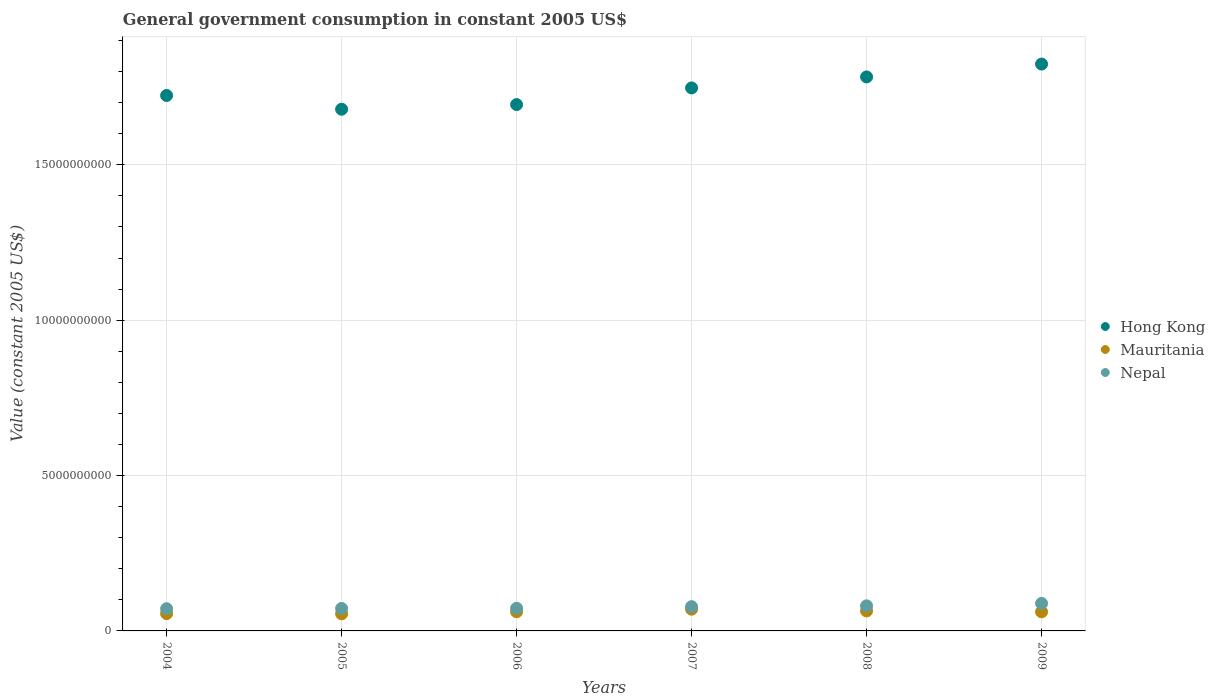How many different coloured dotlines are there?
Your response must be concise. 3. Is the number of dotlines equal to the number of legend labels?
Ensure brevity in your answer.  Yes. What is the government conusmption in Mauritania in 2009?
Offer a terse response. 6.14e+08. Across all years, what is the maximum government conusmption in Mauritania?
Your answer should be compact. 7.00e+08. Across all years, what is the minimum government conusmption in Hong Kong?
Offer a terse response. 1.68e+1. In which year was the government conusmption in Mauritania maximum?
Your answer should be very brief. 2007. In which year was the government conusmption in Hong Kong minimum?
Make the answer very short. 2005. What is the total government conusmption in Mauritania in the graph?
Your response must be concise. 3.68e+09. What is the difference between the government conusmption in Nepal in 2006 and that in 2008?
Keep it short and to the point. -7.78e+07. What is the difference between the government conusmption in Mauritania in 2007 and the government conusmption in Nepal in 2008?
Your answer should be very brief. -1.07e+08. What is the average government conusmption in Mauritania per year?
Offer a terse response. 6.13e+08. In the year 2005, what is the difference between the government conusmption in Mauritania and government conusmption in Hong Kong?
Offer a terse response. -1.62e+1. What is the ratio of the government conusmption in Hong Kong in 2004 to that in 2006?
Keep it short and to the point. 1.02. Is the difference between the government conusmption in Mauritania in 2004 and 2006 greater than the difference between the government conusmption in Hong Kong in 2004 and 2006?
Offer a very short reply. No. What is the difference between the highest and the second highest government conusmption in Nepal?
Offer a very short reply. 7.83e+07. What is the difference between the highest and the lowest government conusmption in Mauritania?
Your response must be concise. 1.49e+08. In how many years, is the government conusmption in Mauritania greater than the average government conusmption in Mauritania taken over all years?
Ensure brevity in your answer.  4. Does the government conusmption in Hong Kong monotonically increase over the years?
Provide a short and direct response. No. Is the government conusmption in Hong Kong strictly greater than the government conusmption in Nepal over the years?
Keep it short and to the point. Yes. How many years are there in the graph?
Give a very brief answer. 6. Are the values on the major ticks of Y-axis written in scientific E-notation?
Offer a terse response. No. How are the legend labels stacked?
Your answer should be very brief. Vertical. What is the title of the graph?
Provide a short and direct response. General government consumption in constant 2005 US$. Does "Hungary" appear as one of the legend labels in the graph?
Your answer should be compact. No. What is the label or title of the X-axis?
Provide a short and direct response. Years. What is the label or title of the Y-axis?
Make the answer very short. Value (constant 2005 US$). What is the Value (constant 2005 US$) in Hong Kong in 2004?
Your answer should be compact. 1.72e+1. What is the Value (constant 2005 US$) in Mauritania in 2004?
Make the answer very short. 5.56e+08. What is the Value (constant 2005 US$) of Nepal in 2004?
Your response must be concise. 7.15e+08. What is the Value (constant 2005 US$) of Hong Kong in 2005?
Give a very brief answer. 1.68e+1. What is the Value (constant 2005 US$) of Mauritania in 2005?
Ensure brevity in your answer.  5.51e+08. What is the Value (constant 2005 US$) in Nepal in 2005?
Make the answer very short. 7.24e+08. What is the Value (constant 2005 US$) of Hong Kong in 2006?
Provide a short and direct response. 1.69e+1. What is the Value (constant 2005 US$) in Mauritania in 2006?
Make the answer very short. 6.17e+08. What is the Value (constant 2005 US$) of Nepal in 2006?
Your answer should be very brief. 7.29e+08. What is the Value (constant 2005 US$) in Hong Kong in 2007?
Give a very brief answer. 1.75e+1. What is the Value (constant 2005 US$) of Mauritania in 2007?
Offer a very short reply. 7.00e+08. What is the Value (constant 2005 US$) in Nepal in 2007?
Offer a terse response. 7.81e+08. What is the Value (constant 2005 US$) of Hong Kong in 2008?
Ensure brevity in your answer.  1.78e+1. What is the Value (constant 2005 US$) of Mauritania in 2008?
Offer a terse response. 6.43e+08. What is the Value (constant 2005 US$) of Nepal in 2008?
Ensure brevity in your answer.  8.07e+08. What is the Value (constant 2005 US$) in Hong Kong in 2009?
Keep it short and to the point. 1.82e+1. What is the Value (constant 2005 US$) of Mauritania in 2009?
Make the answer very short. 6.14e+08. What is the Value (constant 2005 US$) in Nepal in 2009?
Your response must be concise. 8.85e+08. Across all years, what is the maximum Value (constant 2005 US$) in Hong Kong?
Make the answer very short. 1.82e+1. Across all years, what is the maximum Value (constant 2005 US$) of Mauritania?
Offer a terse response. 7.00e+08. Across all years, what is the maximum Value (constant 2005 US$) in Nepal?
Your response must be concise. 8.85e+08. Across all years, what is the minimum Value (constant 2005 US$) in Hong Kong?
Offer a very short reply. 1.68e+1. Across all years, what is the minimum Value (constant 2005 US$) in Mauritania?
Provide a short and direct response. 5.51e+08. Across all years, what is the minimum Value (constant 2005 US$) in Nepal?
Your response must be concise. 7.15e+08. What is the total Value (constant 2005 US$) in Hong Kong in the graph?
Keep it short and to the point. 1.04e+11. What is the total Value (constant 2005 US$) of Mauritania in the graph?
Your answer should be compact. 3.68e+09. What is the total Value (constant 2005 US$) of Nepal in the graph?
Your answer should be very brief. 4.64e+09. What is the difference between the Value (constant 2005 US$) in Hong Kong in 2004 and that in 2005?
Ensure brevity in your answer.  4.43e+08. What is the difference between the Value (constant 2005 US$) in Mauritania in 2004 and that in 2005?
Provide a succinct answer. 5.46e+06. What is the difference between the Value (constant 2005 US$) of Nepal in 2004 and that in 2005?
Make the answer very short. -8.87e+06. What is the difference between the Value (constant 2005 US$) of Hong Kong in 2004 and that in 2006?
Provide a succinct answer. 2.93e+08. What is the difference between the Value (constant 2005 US$) in Mauritania in 2004 and that in 2006?
Give a very brief answer. -6.05e+07. What is the difference between the Value (constant 2005 US$) of Nepal in 2004 and that in 2006?
Make the answer very short. -1.43e+07. What is the difference between the Value (constant 2005 US$) of Hong Kong in 2004 and that in 2007?
Your response must be concise. -2.43e+08. What is the difference between the Value (constant 2005 US$) of Mauritania in 2004 and that in 2007?
Offer a very short reply. -1.44e+08. What is the difference between the Value (constant 2005 US$) of Nepal in 2004 and that in 2007?
Give a very brief answer. -6.66e+07. What is the difference between the Value (constant 2005 US$) of Hong Kong in 2004 and that in 2008?
Make the answer very short. -5.97e+08. What is the difference between the Value (constant 2005 US$) of Mauritania in 2004 and that in 2008?
Give a very brief answer. -8.71e+07. What is the difference between the Value (constant 2005 US$) in Nepal in 2004 and that in 2008?
Ensure brevity in your answer.  -9.21e+07. What is the difference between the Value (constant 2005 US$) in Hong Kong in 2004 and that in 2009?
Your answer should be compact. -1.01e+09. What is the difference between the Value (constant 2005 US$) of Mauritania in 2004 and that in 2009?
Keep it short and to the point. -5.82e+07. What is the difference between the Value (constant 2005 US$) in Nepal in 2004 and that in 2009?
Your response must be concise. -1.70e+08. What is the difference between the Value (constant 2005 US$) of Hong Kong in 2005 and that in 2006?
Give a very brief answer. -1.50e+08. What is the difference between the Value (constant 2005 US$) of Mauritania in 2005 and that in 2006?
Your answer should be very brief. -6.60e+07. What is the difference between the Value (constant 2005 US$) in Nepal in 2005 and that in 2006?
Your answer should be very brief. -5.47e+06. What is the difference between the Value (constant 2005 US$) in Hong Kong in 2005 and that in 2007?
Your answer should be very brief. -6.85e+08. What is the difference between the Value (constant 2005 US$) of Mauritania in 2005 and that in 2007?
Your answer should be very brief. -1.49e+08. What is the difference between the Value (constant 2005 US$) in Nepal in 2005 and that in 2007?
Keep it short and to the point. -5.77e+07. What is the difference between the Value (constant 2005 US$) in Hong Kong in 2005 and that in 2008?
Make the answer very short. -1.04e+09. What is the difference between the Value (constant 2005 US$) in Mauritania in 2005 and that in 2008?
Ensure brevity in your answer.  -9.26e+07. What is the difference between the Value (constant 2005 US$) of Nepal in 2005 and that in 2008?
Your response must be concise. -8.33e+07. What is the difference between the Value (constant 2005 US$) of Hong Kong in 2005 and that in 2009?
Offer a very short reply. -1.45e+09. What is the difference between the Value (constant 2005 US$) in Mauritania in 2005 and that in 2009?
Ensure brevity in your answer.  -6.36e+07. What is the difference between the Value (constant 2005 US$) of Nepal in 2005 and that in 2009?
Offer a very short reply. -1.62e+08. What is the difference between the Value (constant 2005 US$) of Hong Kong in 2006 and that in 2007?
Provide a short and direct response. -5.36e+08. What is the difference between the Value (constant 2005 US$) of Mauritania in 2006 and that in 2007?
Give a very brief answer. -8.31e+07. What is the difference between the Value (constant 2005 US$) of Nepal in 2006 and that in 2007?
Offer a very short reply. -5.22e+07. What is the difference between the Value (constant 2005 US$) of Hong Kong in 2006 and that in 2008?
Ensure brevity in your answer.  -8.89e+08. What is the difference between the Value (constant 2005 US$) in Mauritania in 2006 and that in 2008?
Give a very brief answer. -2.66e+07. What is the difference between the Value (constant 2005 US$) of Nepal in 2006 and that in 2008?
Ensure brevity in your answer.  -7.78e+07. What is the difference between the Value (constant 2005 US$) in Hong Kong in 2006 and that in 2009?
Keep it short and to the point. -1.30e+09. What is the difference between the Value (constant 2005 US$) of Mauritania in 2006 and that in 2009?
Ensure brevity in your answer.  2.38e+06. What is the difference between the Value (constant 2005 US$) of Nepal in 2006 and that in 2009?
Offer a terse response. -1.56e+08. What is the difference between the Value (constant 2005 US$) of Hong Kong in 2007 and that in 2008?
Give a very brief answer. -3.54e+08. What is the difference between the Value (constant 2005 US$) of Mauritania in 2007 and that in 2008?
Offer a very short reply. 5.65e+07. What is the difference between the Value (constant 2005 US$) of Nepal in 2007 and that in 2008?
Provide a short and direct response. -2.56e+07. What is the difference between the Value (constant 2005 US$) of Hong Kong in 2007 and that in 2009?
Provide a short and direct response. -7.68e+08. What is the difference between the Value (constant 2005 US$) in Mauritania in 2007 and that in 2009?
Your answer should be very brief. 8.54e+07. What is the difference between the Value (constant 2005 US$) of Nepal in 2007 and that in 2009?
Your answer should be compact. -1.04e+08. What is the difference between the Value (constant 2005 US$) of Hong Kong in 2008 and that in 2009?
Make the answer very short. -4.14e+08. What is the difference between the Value (constant 2005 US$) in Mauritania in 2008 and that in 2009?
Offer a terse response. 2.89e+07. What is the difference between the Value (constant 2005 US$) in Nepal in 2008 and that in 2009?
Give a very brief answer. -7.83e+07. What is the difference between the Value (constant 2005 US$) of Hong Kong in 2004 and the Value (constant 2005 US$) of Mauritania in 2005?
Offer a terse response. 1.67e+1. What is the difference between the Value (constant 2005 US$) in Hong Kong in 2004 and the Value (constant 2005 US$) in Nepal in 2005?
Offer a terse response. 1.65e+1. What is the difference between the Value (constant 2005 US$) of Mauritania in 2004 and the Value (constant 2005 US$) of Nepal in 2005?
Your answer should be very brief. -1.67e+08. What is the difference between the Value (constant 2005 US$) of Hong Kong in 2004 and the Value (constant 2005 US$) of Mauritania in 2006?
Give a very brief answer. 1.66e+1. What is the difference between the Value (constant 2005 US$) of Hong Kong in 2004 and the Value (constant 2005 US$) of Nepal in 2006?
Your response must be concise. 1.65e+1. What is the difference between the Value (constant 2005 US$) in Mauritania in 2004 and the Value (constant 2005 US$) in Nepal in 2006?
Offer a very short reply. -1.73e+08. What is the difference between the Value (constant 2005 US$) in Hong Kong in 2004 and the Value (constant 2005 US$) in Mauritania in 2007?
Keep it short and to the point. 1.65e+1. What is the difference between the Value (constant 2005 US$) of Hong Kong in 2004 and the Value (constant 2005 US$) of Nepal in 2007?
Your response must be concise. 1.64e+1. What is the difference between the Value (constant 2005 US$) in Mauritania in 2004 and the Value (constant 2005 US$) in Nepal in 2007?
Give a very brief answer. -2.25e+08. What is the difference between the Value (constant 2005 US$) in Hong Kong in 2004 and the Value (constant 2005 US$) in Mauritania in 2008?
Your answer should be compact. 1.66e+1. What is the difference between the Value (constant 2005 US$) in Hong Kong in 2004 and the Value (constant 2005 US$) in Nepal in 2008?
Give a very brief answer. 1.64e+1. What is the difference between the Value (constant 2005 US$) in Mauritania in 2004 and the Value (constant 2005 US$) in Nepal in 2008?
Your answer should be very brief. -2.51e+08. What is the difference between the Value (constant 2005 US$) of Hong Kong in 2004 and the Value (constant 2005 US$) of Mauritania in 2009?
Offer a very short reply. 1.66e+1. What is the difference between the Value (constant 2005 US$) in Hong Kong in 2004 and the Value (constant 2005 US$) in Nepal in 2009?
Keep it short and to the point. 1.63e+1. What is the difference between the Value (constant 2005 US$) in Mauritania in 2004 and the Value (constant 2005 US$) in Nepal in 2009?
Ensure brevity in your answer.  -3.29e+08. What is the difference between the Value (constant 2005 US$) in Hong Kong in 2005 and the Value (constant 2005 US$) in Mauritania in 2006?
Ensure brevity in your answer.  1.62e+1. What is the difference between the Value (constant 2005 US$) of Hong Kong in 2005 and the Value (constant 2005 US$) of Nepal in 2006?
Ensure brevity in your answer.  1.61e+1. What is the difference between the Value (constant 2005 US$) in Mauritania in 2005 and the Value (constant 2005 US$) in Nepal in 2006?
Your answer should be compact. -1.78e+08. What is the difference between the Value (constant 2005 US$) in Hong Kong in 2005 and the Value (constant 2005 US$) in Mauritania in 2007?
Keep it short and to the point. 1.61e+1. What is the difference between the Value (constant 2005 US$) of Hong Kong in 2005 and the Value (constant 2005 US$) of Nepal in 2007?
Make the answer very short. 1.60e+1. What is the difference between the Value (constant 2005 US$) in Mauritania in 2005 and the Value (constant 2005 US$) in Nepal in 2007?
Give a very brief answer. -2.31e+08. What is the difference between the Value (constant 2005 US$) in Hong Kong in 2005 and the Value (constant 2005 US$) in Mauritania in 2008?
Make the answer very short. 1.61e+1. What is the difference between the Value (constant 2005 US$) of Hong Kong in 2005 and the Value (constant 2005 US$) of Nepal in 2008?
Your answer should be compact. 1.60e+1. What is the difference between the Value (constant 2005 US$) in Mauritania in 2005 and the Value (constant 2005 US$) in Nepal in 2008?
Give a very brief answer. -2.56e+08. What is the difference between the Value (constant 2005 US$) in Hong Kong in 2005 and the Value (constant 2005 US$) in Mauritania in 2009?
Keep it short and to the point. 1.62e+1. What is the difference between the Value (constant 2005 US$) in Hong Kong in 2005 and the Value (constant 2005 US$) in Nepal in 2009?
Offer a very short reply. 1.59e+1. What is the difference between the Value (constant 2005 US$) in Mauritania in 2005 and the Value (constant 2005 US$) in Nepal in 2009?
Ensure brevity in your answer.  -3.34e+08. What is the difference between the Value (constant 2005 US$) of Hong Kong in 2006 and the Value (constant 2005 US$) of Mauritania in 2007?
Provide a short and direct response. 1.62e+1. What is the difference between the Value (constant 2005 US$) in Hong Kong in 2006 and the Value (constant 2005 US$) in Nepal in 2007?
Your response must be concise. 1.62e+1. What is the difference between the Value (constant 2005 US$) in Mauritania in 2006 and the Value (constant 2005 US$) in Nepal in 2007?
Provide a short and direct response. -1.65e+08. What is the difference between the Value (constant 2005 US$) of Hong Kong in 2006 and the Value (constant 2005 US$) of Mauritania in 2008?
Give a very brief answer. 1.63e+1. What is the difference between the Value (constant 2005 US$) in Hong Kong in 2006 and the Value (constant 2005 US$) in Nepal in 2008?
Ensure brevity in your answer.  1.61e+1. What is the difference between the Value (constant 2005 US$) of Mauritania in 2006 and the Value (constant 2005 US$) of Nepal in 2008?
Your answer should be compact. -1.90e+08. What is the difference between the Value (constant 2005 US$) in Hong Kong in 2006 and the Value (constant 2005 US$) in Mauritania in 2009?
Provide a short and direct response. 1.63e+1. What is the difference between the Value (constant 2005 US$) in Hong Kong in 2006 and the Value (constant 2005 US$) in Nepal in 2009?
Keep it short and to the point. 1.61e+1. What is the difference between the Value (constant 2005 US$) of Mauritania in 2006 and the Value (constant 2005 US$) of Nepal in 2009?
Ensure brevity in your answer.  -2.68e+08. What is the difference between the Value (constant 2005 US$) in Hong Kong in 2007 and the Value (constant 2005 US$) in Mauritania in 2008?
Offer a very short reply. 1.68e+1. What is the difference between the Value (constant 2005 US$) in Hong Kong in 2007 and the Value (constant 2005 US$) in Nepal in 2008?
Your answer should be very brief. 1.67e+1. What is the difference between the Value (constant 2005 US$) of Mauritania in 2007 and the Value (constant 2005 US$) of Nepal in 2008?
Provide a short and direct response. -1.07e+08. What is the difference between the Value (constant 2005 US$) of Hong Kong in 2007 and the Value (constant 2005 US$) of Mauritania in 2009?
Your answer should be very brief. 1.69e+1. What is the difference between the Value (constant 2005 US$) of Hong Kong in 2007 and the Value (constant 2005 US$) of Nepal in 2009?
Provide a short and direct response. 1.66e+1. What is the difference between the Value (constant 2005 US$) of Mauritania in 2007 and the Value (constant 2005 US$) of Nepal in 2009?
Ensure brevity in your answer.  -1.85e+08. What is the difference between the Value (constant 2005 US$) in Hong Kong in 2008 and the Value (constant 2005 US$) in Mauritania in 2009?
Offer a terse response. 1.72e+1. What is the difference between the Value (constant 2005 US$) of Hong Kong in 2008 and the Value (constant 2005 US$) of Nepal in 2009?
Ensure brevity in your answer.  1.69e+1. What is the difference between the Value (constant 2005 US$) of Mauritania in 2008 and the Value (constant 2005 US$) of Nepal in 2009?
Your answer should be compact. -2.42e+08. What is the average Value (constant 2005 US$) in Hong Kong per year?
Provide a succinct answer. 1.74e+1. What is the average Value (constant 2005 US$) in Mauritania per year?
Provide a succinct answer. 6.13e+08. What is the average Value (constant 2005 US$) of Nepal per year?
Your answer should be compact. 7.73e+08. In the year 2004, what is the difference between the Value (constant 2005 US$) in Hong Kong and Value (constant 2005 US$) in Mauritania?
Provide a succinct answer. 1.67e+1. In the year 2004, what is the difference between the Value (constant 2005 US$) of Hong Kong and Value (constant 2005 US$) of Nepal?
Make the answer very short. 1.65e+1. In the year 2004, what is the difference between the Value (constant 2005 US$) in Mauritania and Value (constant 2005 US$) in Nepal?
Keep it short and to the point. -1.59e+08. In the year 2005, what is the difference between the Value (constant 2005 US$) of Hong Kong and Value (constant 2005 US$) of Mauritania?
Provide a succinct answer. 1.62e+1. In the year 2005, what is the difference between the Value (constant 2005 US$) of Hong Kong and Value (constant 2005 US$) of Nepal?
Provide a succinct answer. 1.61e+1. In the year 2005, what is the difference between the Value (constant 2005 US$) in Mauritania and Value (constant 2005 US$) in Nepal?
Your answer should be very brief. -1.73e+08. In the year 2006, what is the difference between the Value (constant 2005 US$) in Hong Kong and Value (constant 2005 US$) in Mauritania?
Ensure brevity in your answer.  1.63e+1. In the year 2006, what is the difference between the Value (constant 2005 US$) in Hong Kong and Value (constant 2005 US$) in Nepal?
Provide a short and direct response. 1.62e+1. In the year 2006, what is the difference between the Value (constant 2005 US$) in Mauritania and Value (constant 2005 US$) in Nepal?
Keep it short and to the point. -1.12e+08. In the year 2007, what is the difference between the Value (constant 2005 US$) in Hong Kong and Value (constant 2005 US$) in Mauritania?
Keep it short and to the point. 1.68e+1. In the year 2007, what is the difference between the Value (constant 2005 US$) of Hong Kong and Value (constant 2005 US$) of Nepal?
Your answer should be compact. 1.67e+1. In the year 2007, what is the difference between the Value (constant 2005 US$) of Mauritania and Value (constant 2005 US$) of Nepal?
Keep it short and to the point. -8.15e+07. In the year 2008, what is the difference between the Value (constant 2005 US$) in Hong Kong and Value (constant 2005 US$) in Mauritania?
Ensure brevity in your answer.  1.72e+1. In the year 2008, what is the difference between the Value (constant 2005 US$) of Hong Kong and Value (constant 2005 US$) of Nepal?
Your response must be concise. 1.70e+1. In the year 2008, what is the difference between the Value (constant 2005 US$) in Mauritania and Value (constant 2005 US$) in Nepal?
Provide a succinct answer. -1.64e+08. In the year 2009, what is the difference between the Value (constant 2005 US$) of Hong Kong and Value (constant 2005 US$) of Mauritania?
Your answer should be compact. 1.76e+1. In the year 2009, what is the difference between the Value (constant 2005 US$) of Hong Kong and Value (constant 2005 US$) of Nepal?
Your answer should be compact. 1.74e+1. In the year 2009, what is the difference between the Value (constant 2005 US$) of Mauritania and Value (constant 2005 US$) of Nepal?
Ensure brevity in your answer.  -2.71e+08. What is the ratio of the Value (constant 2005 US$) of Hong Kong in 2004 to that in 2005?
Provide a succinct answer. 1.03. What is the ratio of the Value (constant 2005 US$) of Mauritania in 2004 to that in 2005?
Provide a short and direct response. 1.01. What is the ratio of the Value (constant 2005 US$) in Hong Kong in 2004 to that in 2006?
Provide a succinct answer. 1.02. What is the ratio of the Value (constant 2005 US$) of Mauritania in 2004 to that in 2006?
Make the answer very short. 0.9. What is the ratio of the Value (constant 2005 US$) of Nepal in 2004 to that in 2006?
Keep it short and to the point. 0.98. What is the ratio of the Value (constant 2005 US$) of Hong Kong in 2004 to that in 2007?
Your answer should be compact. 0.99. What is the ratio of the Value (constant 2005 US$) in Mauritania in 2004 to that in 2007?
Your answer should be very brief. 0.79. What is the ratio of the Value (constant 2005 US$) of Nepal in 2004 to that in 2007?
Your response must be concise. 0.91. What is the ratio of the Value (constant 2005 US$) in Hong Kong in 2004 to that in 2008?
Ensure brevity in your answer.  0.97. What is the ratio of the Value (constant 2005 US$) of Mauritania in 2004 to that in 2008?
Give a very brief answer. 0.86. What is the ratio of the Value (constant 2005 US$) of Nepal in 2004 to that in 2008?
Offer a very short reply. 0.89. What is the ratio of the Value (constant 2005 US$) in Hong Kong in 2004 to that in 2009?
Make the answer very short. 0.94. What is the ratio of the Value (constant 2005 US$) in Mauritania in 2004 to that in 2009?
Provide a short and direct response. 0.91. What is the ratio of the Value (constant 2005 US$) of Nepal in 2004 to that in 2009?
Keep it short and to the point. 0.81. What is the ratio of the Value (constant 2005 US$) in Hong Kong in 2005 to that in 2006?
Make the answer very short. 0.99. What is the ratio of the Value (constant 2005 US$) of Mauritania in 2005 to that in 2006?
Give a very brief answer. 0.89. What is the ratio of the Value (constant 2005 US$) of Hong Kong in 2005 to that in 2007?
Give a very brief answer. 0.96. What is the ratio of the Value (constant 2005 US$) of Mauritania in 2005 to that in 2007?
Offer a very short reply. 0.79. What is the ratio of the Value (constant 2005 US$) of Nepal in 2005 to that in 2007?
Provide a short and direct response. 0.93. What is the ratio of the Value (constant 2005 US$) in Hong Kong in 2005 to that in 2008?
Offer a terse response. 0.94. What is the ratio of the Value (constant 2005 US$) of Mauritania in 2005 to that in 2008?
Your answer should be very brief. 0.86. What is the ratio of the Value (constant 2005 US$) in Nepal in 2005 to that in 2008?
Ensure brevity in your answer.  0.9. What is the ratio of the Value (constant 2005 US$) in Hong Kong in 2005 to that in 2009?
Give a very brief answer. 0.92. What is the ratio of the Value (constant 2005 US$) in Mauritania in 2005 to that in 2009?
Ensure brevity in your answer.  0.9. What is the ratio of the Value (constant 2005 US$) in Nepal in 2005 to that in 2009?
Your answer should be very brief. 0.82. What is the ratio of the Value (constant 2005 US$) of Hong Kong in 2006 to that in 2007?
Ensure brevity in your answer.  0.97. What is the ratio of the Value (constant 2005 US$) in Mauritania in 2006 to that in 2007?
Provide a succinct answer. 0.88. What is the ratio of the Value (constant 2005 US$) of Nepal in 2006 to that in 2007?
Offer a very short reply. 0.93. What is the ratio of the Value (constant 2005 US$) in Hong Kong in 2006 to that in 2008?
Make the answer very short. 0.95. What is the ratio of the Value (constant 2005 US$) in Mauritania in 2006 to that in 2008?
Ensure brevity in your answer.  0.96. What is the ratio of the Value (constant 2005 US$) in Nepal in 2006 to that in 2008?
Ensure brevity in your answer.  0.9. What is the ratio of the Value (constant 2005 US$) in Hong Kong in 2006 to that in 2009?
Keep it short and to the point. 0.93. What is the ratio of the Value (constant 2005 US$) of Mauritania in 2006 to that in 2009?
Provide a short and direct response. 1. What is the ratio of the Value (constant 2005 US$) in Nepal in 2006 to that in 2009?
Keep it short and to the point. 0.82. What is the ratio of the Value (constant 2005 US$) in Hong Kong in 2007 to that in 2008?
Provide a short and direct response. 0.98. What is the ratio of the Value (constant 2005 US$) in Mauritania in 2007 to that in 2008?
Give a very brief answer. 1.09. What is the ratio of the Value (constant 2005 US$) in Nepal in 2007 to that in 2008?
Give a very brief answer. 0.97. What is the ratio of the Value (constant 2005 US$) in Hong Kong in 2007 to that in 2009?
Your answer should be compact. 0.96. What is the ratio of the Value (constant 2005 US$) of Mauritania in 2007 to that in 2009?
Your answer should be compact. 1.14. What is the ratio of the Value (constant 2005 US$) in Nepal in 2007 to that in 2009?
Your answer should be compact. 0.88. What is the ratio of the Value (constant 2005 US$) in Hong Kong in 2008 to that in 2009?
Provide a short and direct response. 0.98. What is the ratio of the Value (constant 2005 US$) of Mauritania in 2008 to that in 2009?
Make the answer very short. 1.05. What is the ratio of the Value (constant 2005 US$) of Nepal in 2008 to that in 2009?
Keep it short and to the point. 0.91. What is the difference between the highest and the second highest Value (constant 2005 US$) of Hong Kong?
Ensure brevity in your answer.  4.14e+08. What is the difference between the highest and the second highest Value (constant 2005 US$) of Mauritania?
Keep it short and to the point. 5.65e+07. What is the difference between the highest and the second highest Value (constant 2005 US$) of Nepal?
Your response must be concise. 7.83e+07. What is the difference between the highest and the lowest Value (constant 2005 US$) of Hong Kong?
Ensure brevity in your answer.  1.45e+09. What is the difference between the highest and the lowest Value (constant 2005 US$) in Mauritania?
Offer a terse response. 1.49e+08. What is the difference between the highest and the lowest Value (constant 2005 US$) in Nepal?
Give a very brief answer. 1.70e+08. 